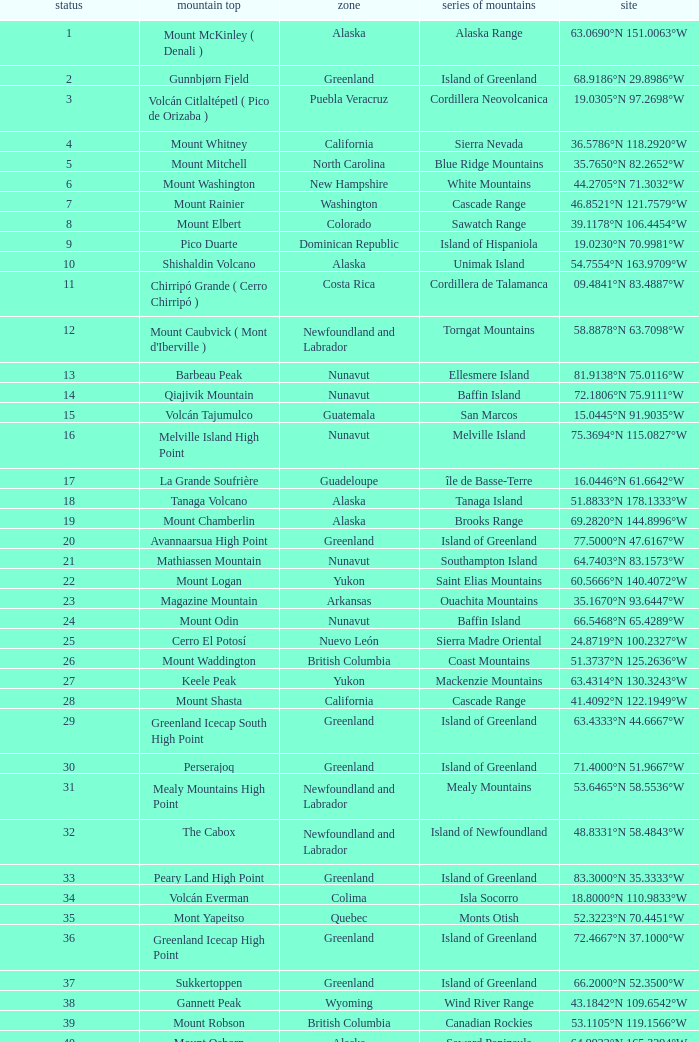Name the Region with a Mountain Peak of dillingham high point? Alaska. 